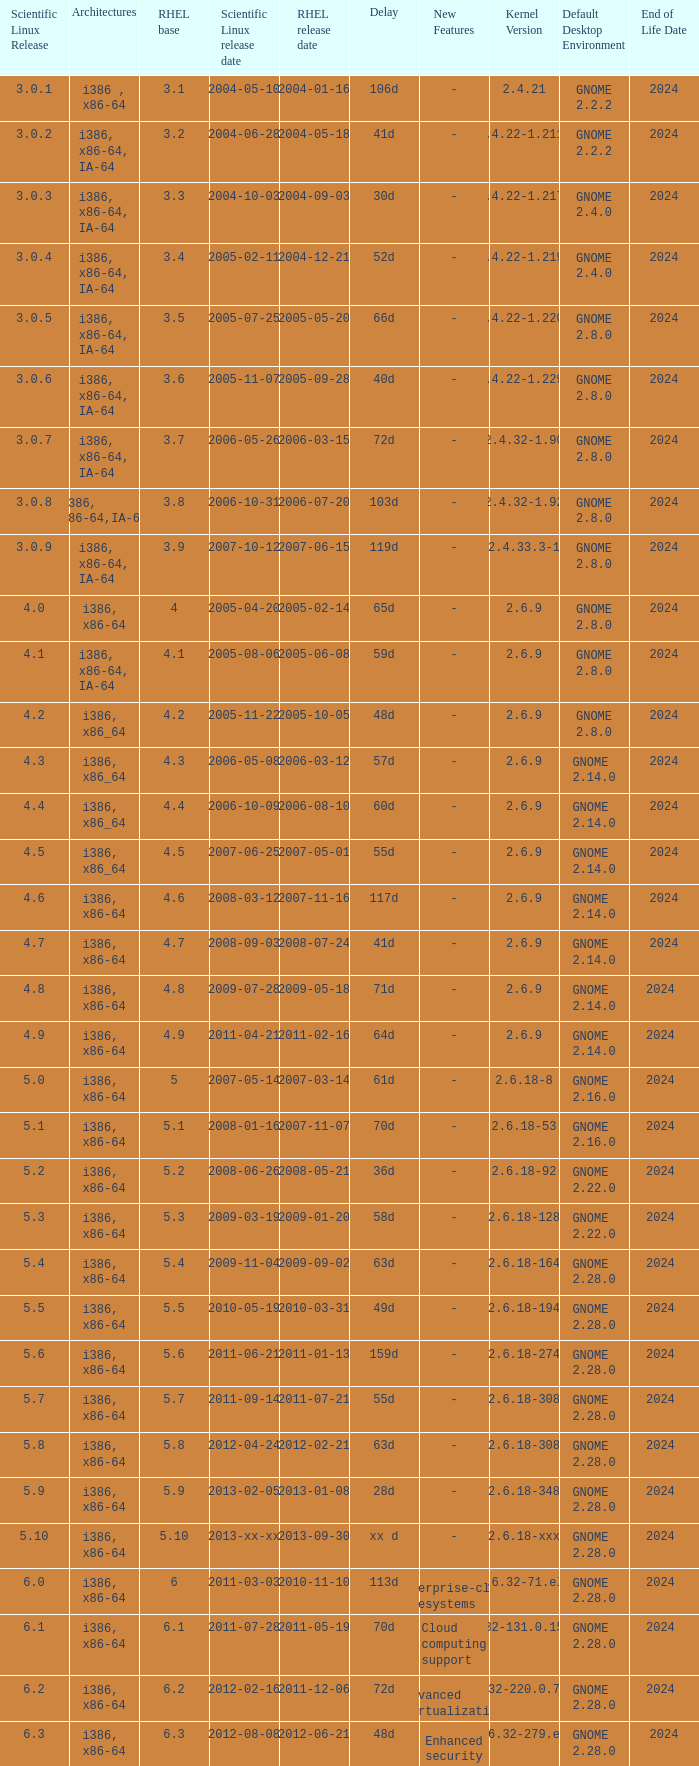Name the scientific linux release when delay is 28d 5.9. 